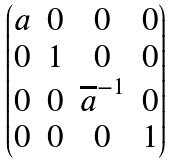<formula> <loc_0><loc_0><loc_500><loc_500>\begin{pmatrix} a & 0 & 0 & 0 \\ 0 & 1 & 0 & 0 \\ 0 & 0 & \overline { a } ^ { - 1 } & 0 \\ 0 & 0 & 0 & 1 \\ \end{pmatrix}</formula> 